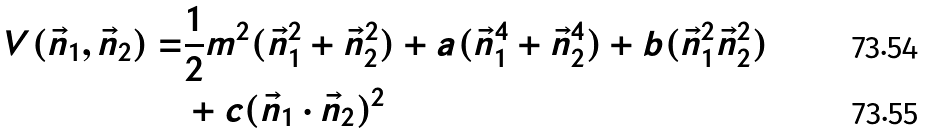<formula> <loc_0><loc_0><loc_500><loc_500>V ( \vec { n } _ { 1 } , \vec { n } _ { 2 } ) = & \frac { 1 } { 2 } m ^ { 2 } ( \vec { n } _ { 1 } ^ { 2 } + \vec { n } _ { 2 } ^ { 2 } ) + a ( \vec { n } _ { 1 } ^ { 4 } + \vec { n } _ { 2 } ^ { 4 } ) + b ( \vec { n } _ { 1 } ^ { 2 } \vec { n } _ { 2 } ^ { 2 } ) \\ & + c ( \vec { n } _ { 1 } \cdot \vec { n } _ { 2 } ) ^ { 2 }</formula> 